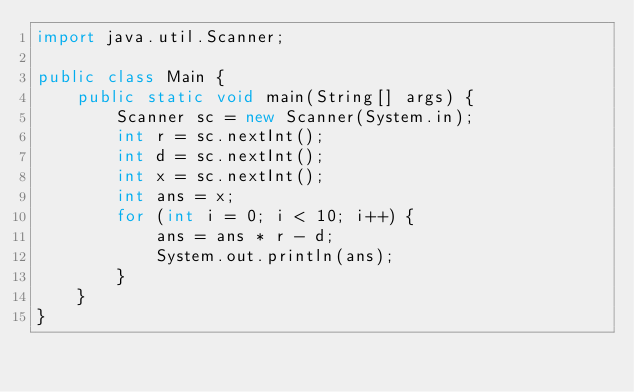Convert code to text. <code><loc_0><loc_0><loc_500><loc_500><_Java_>import java.util.Scanner;

public class Main {
    public static void main(String[] args) {
        Scanner sc = new Scanner(System.in);
        int r = sc.nextInt();
        int d = sc.nextInt();
        int x = sc.nextInt();
        int ans = x;
        for (int i = 0; i < 10; i++) {
            ans = ans * r - d;
            System.out.println(ans);
        }
    }
}</code> 